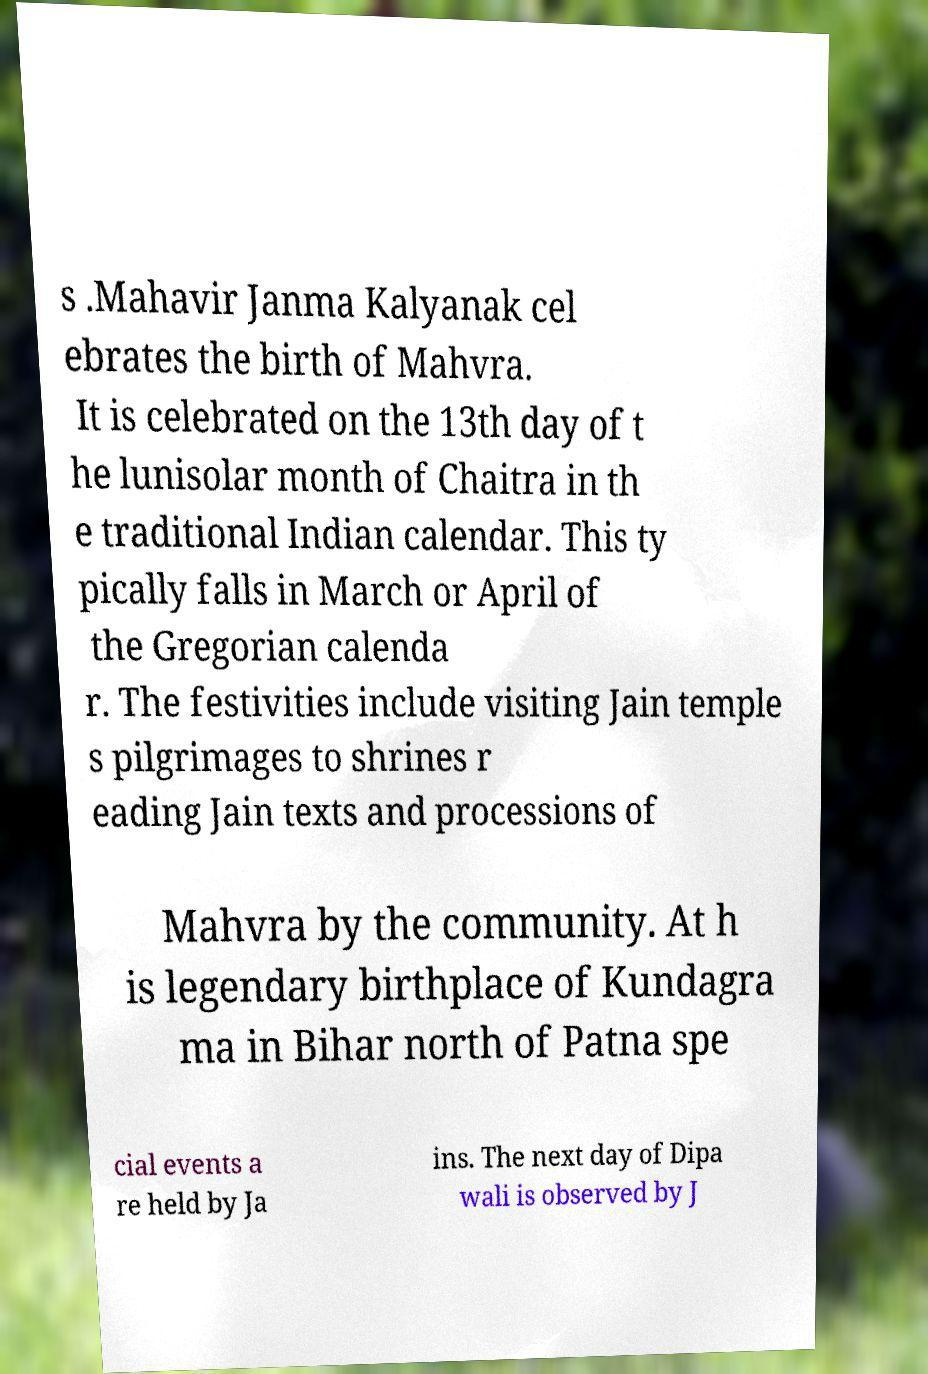I need the written content from this picture converted into text. Can you do that? s .Mahavir Janma Kalyanak cel ebrates the birth of Mahvra. It is celebrated on the 13th day of t he lunisolar month of Chaitra in th e traditional Indian calendar. This ty pically falls in March or April of the Gregorian calenda r. The festivities include visiting Jain temple s pilgrimages to shrines r eading Jain texts and processions of Mahvra by the community. At h is legendary birthplace of Kundagra ma in Bihar north of Patna spe cial events a re held by Ja ins. The next day of Dipa wali is observed by J 